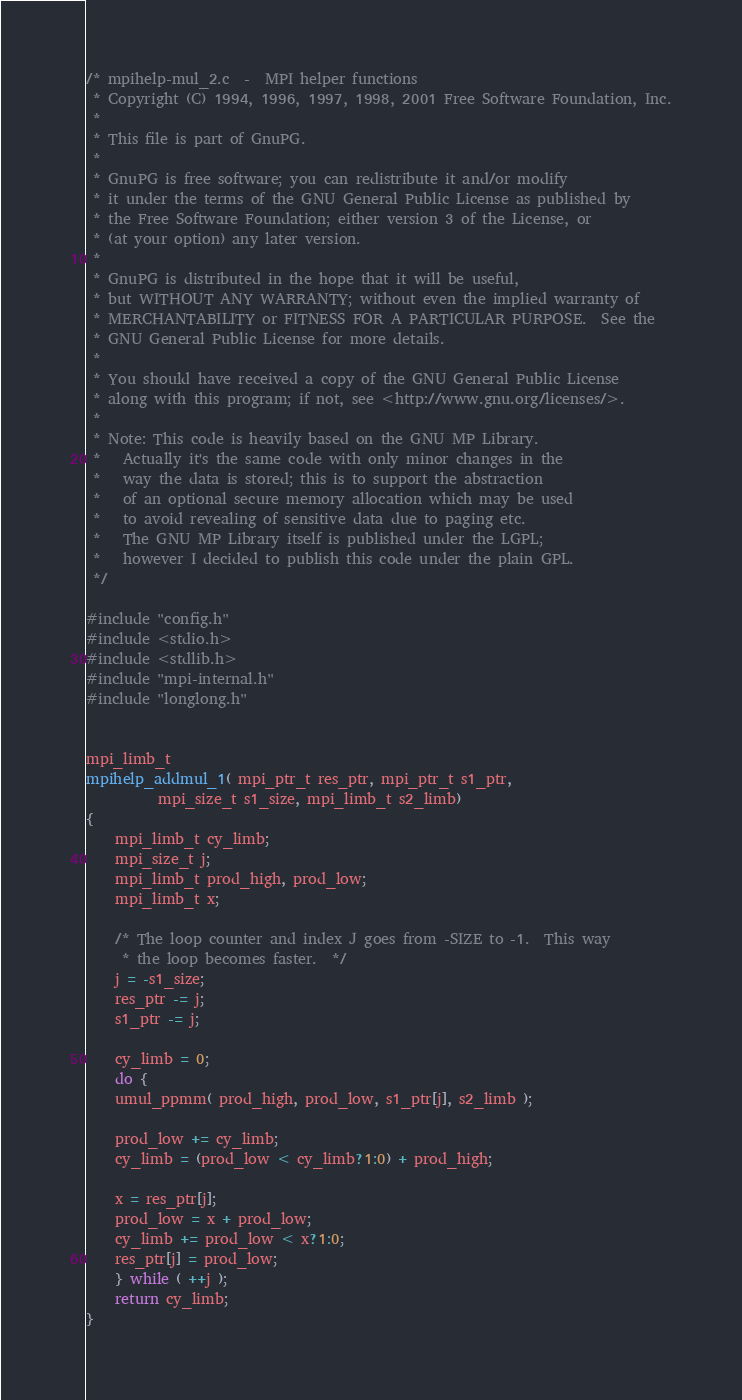<code> <loc_0><loc_0><loc_500><loc_500><_C_>/* mpihelp-mul_2.c  -  MPI helper functions
 * Copyright (C) 1994, 1996, 1997, 1998, 2001 Free Software Foundation, Inc.
 *
 * This file is part of GnuPG.
 *
 * GnuPG is free software; you can redistribute it and/or modify
 * it under the terms of the GNU General Public License as published by
 * the Free Software Foundation; either version 3 of the License, or
 * (at your option) any later version.
 *
 * GnuPG is distributed in the hope that it will be useful,
 * but WITHOUT ANY WARRANTY; without even the implied warranty of
 * MERCHANTABILITY or FITNESS FOR A PARTICULAR PURPOSE.  See the
 * GNU General Public License for more details.
 *
 * You should have received a copy of the GNU General Public License
 * along with this program; if not, see <http://www.gnu.org/licenses/>.
 *
 * Note: This code is heavily based on the GNU MP Library.
 *	 Actually it's the same code with only minor changes in the
 *	 way the data is stored; this is to support the abstraction
 *	 of an optional secure memory allocation which may be used
 *	 to avoid revealing of sensitive data due to paging etc.
 *	 The GNU MP Library itself is published under the LGPL;
 *	 however I decided to publish this code under the plain GPL.
 */

#include "config.h"
#include <stdio.h>
#include <stdlib.h>
#include "mpi-internal.h"
#include "longlong.h"


mpi_limb_t
mpihelp_addmul_1( mpi_ptr_t res_ptr, mpi_ptr_t s1_ptr,
		  mpi_size_t s1_size, mpi_limb_t s2_limb)
{
    mpi_limb_t cy_limb;
    mpi_size_t j;
    mpi_limb_t prod_high, prod_low;
    mpi_limb_t x;

    /* The loop counter and index J goes from -SIZE to -1.  This way
     * the loop becomes faster.  */
    j = -s1_size;
    res_ptr -= j;
    s1_ptr -= j;

    cy_limb = 0;
    do {
	umul_ppmm( prod_high, prod_low, s1_ptr[j], s2_limb );

	prod_low += cy_limb;
	cy_limb = (prod_low < cy_limb?1:0) + prod_high;

	x = res_ptr[j];
	prod_low = x + prod_low;
	cy_limb += prod_low < x?1:0;
	res_ptr[j] = prod_low;
    } while ( ++j );
    return cy_limb;
}


</code> 